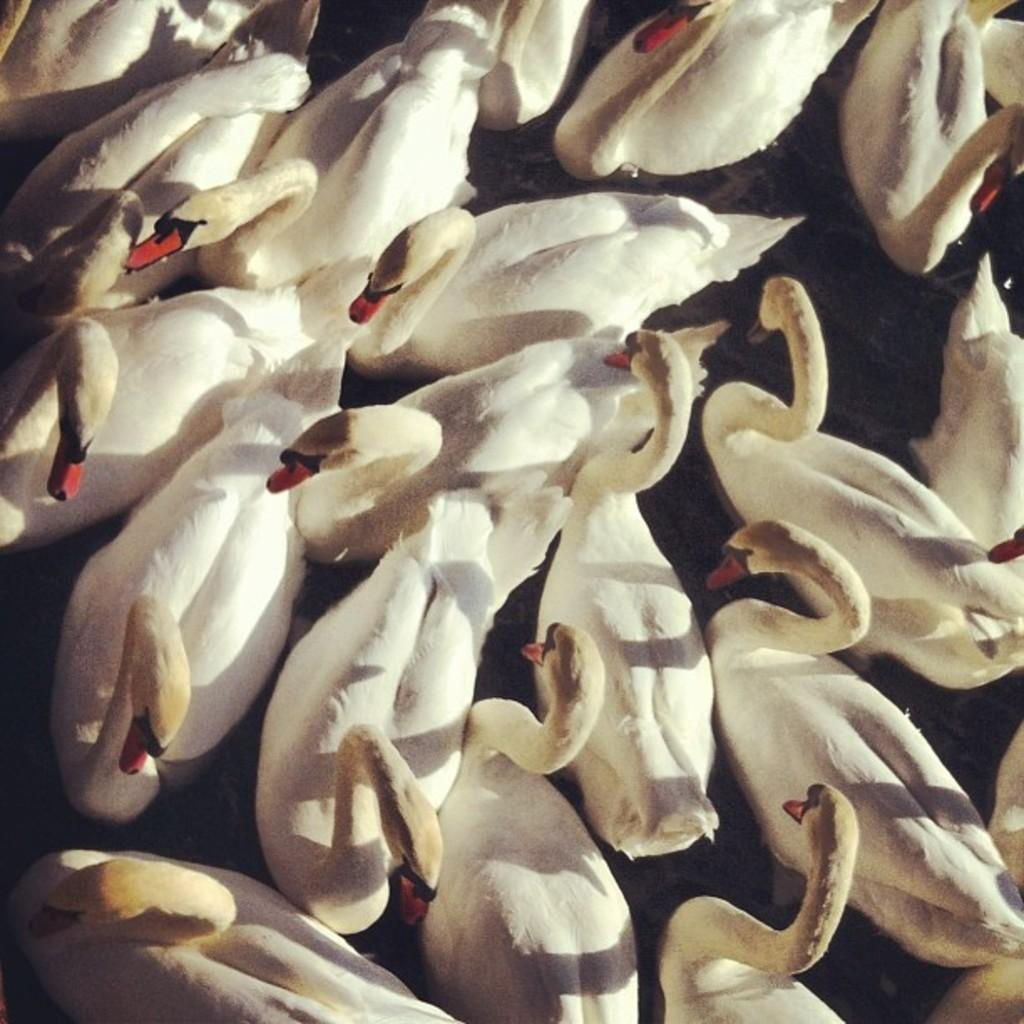What type of animals are in the image? There are swans in the image. Can you describe the coloring of the swans? The swans have white, black, and red coloring. What type of prison can be seen in the image? There is no prison present in the image; it features swans with white, black, and red coloring. How many jellyfish are swimming in the image? There are no jellyfish present in the image; it features swans with white, black, and red coloring. 